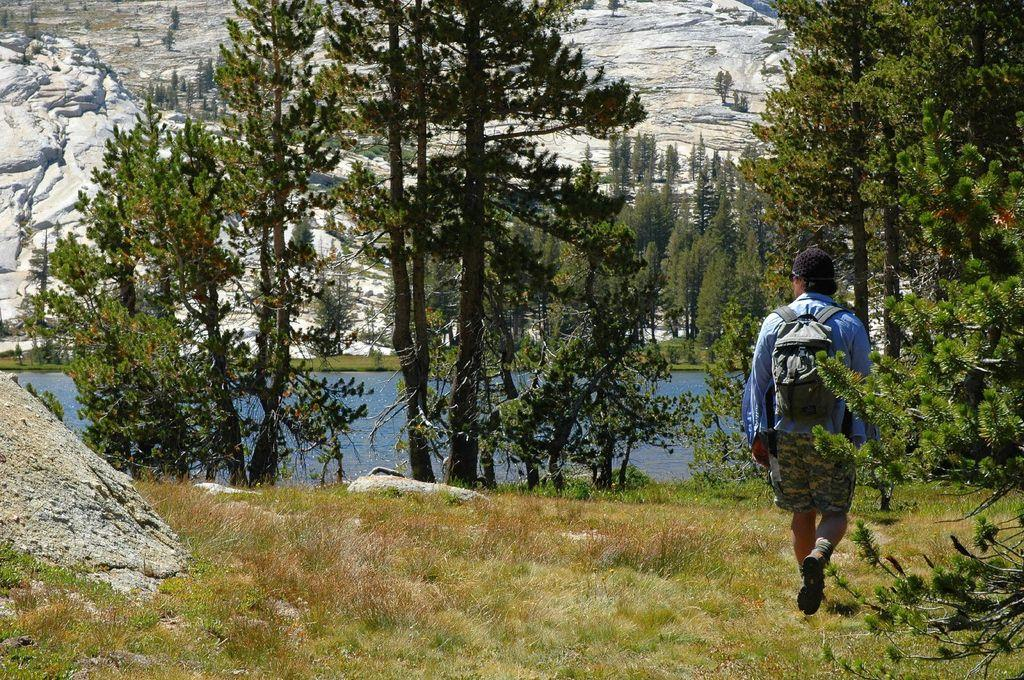What is the man in the image doing? The man is walking on the right side of the image. What is the man wearing? The man is wearing a shirt and shorts. Is the man carrying anything in the image? Yes, the man is carrying a bag. What can be seen in the middle of the image? There are trees and water in the middle of the image. What type of bone is the man holding in the image? There is no bone present in the image; the man is carrying a bag. Is there a scarecrow in the image? No, there is no scarecrow in the image. 